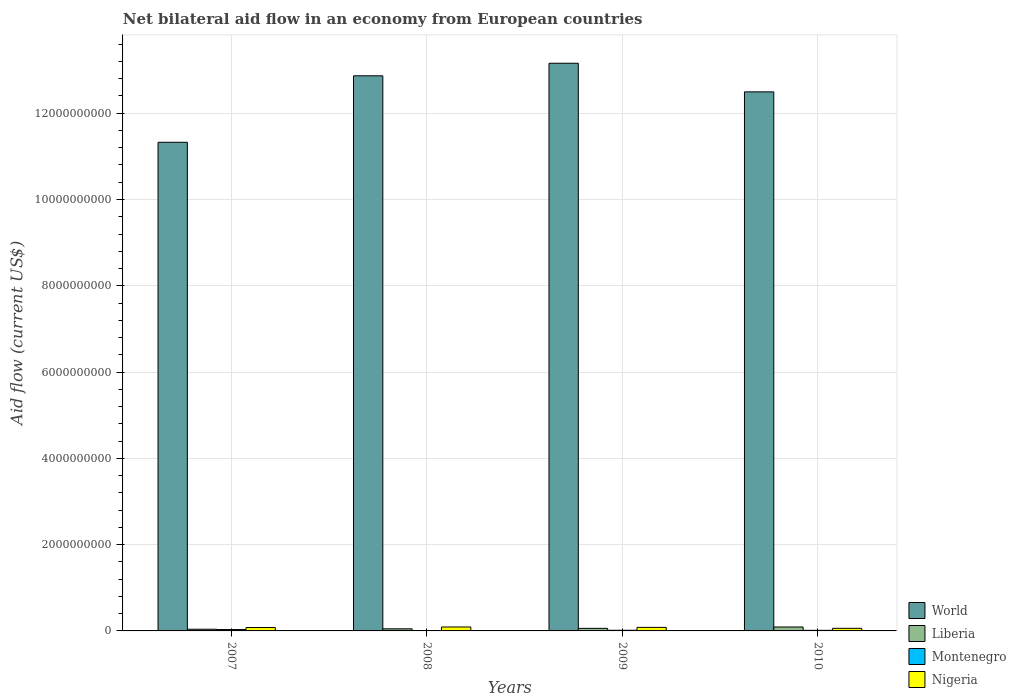How many groups of bars are there?
Your answer should be compact. 4. Are the number of bars per tick equal to the number of legend labels?
Your answer should be compact. Yes. Are the number of bars on each tick of the X-axis equal?
Ensure brevity in your answer.  Yes. How many bars are there on the 3rd tick from the left?
Provide a succinct answer. 4. How many bars are there on the 4th tick from the right?
Offer a very short reply. 4. What is the label of the 3rd group of bars from the left?
Offer a terse response. 2009. In how many cases, is the number of bars for a given year not equal to the number of legend labels?
Offer a very short reply. 0. What is the net bilateral aid flow in World in 2007?
Give a very brief answer. 1.13e+1. Across all years, what is the maximum net bilateral aid flow in World?
Keep it short and to the point. 1.32e+1. Across all years, what is the minimum net bilateral aid flow in Liberia?
Your response must be concise. 3.95e+07. In which year was the net bilateral aid flow in Liberia maximum?
Offer a very short reply. 2010. In which year was the net bilateral aid flow in Liberia minimum?
Give a very brief answer. 2007. What is the total net bilateral aid flow in World in the graph?
Provide a short and direct response. 4.98e+1. What is the difference between the net bilateral aid flow in Montenegro in 2008 and that in 2010?
Give a very brief answer. -4.20e+06. What is the difference between the net bilateral aid flow in Nigeria in 2007 and the net bilateral aid flow in Montenegro in 2008?
Your answer should be very brief. 6.90e+07. What is the average net bilateral aid flow in Montenegro per year?
Ensure brevity in your answer.  1.74e+07. In the year 2008, what is the difference between the net bilateral aid flow in World and net bilateral aid flow in Nigeria?
Make the answer very short. 1.28e+1. What is the ratio of the net bilateral aid flow in World in 2009 to that in 2010?
Your response must be concise. 1.05. Is the net bilateral aid flow in Liberia in 2007 less than that in 2010?
Your answer should be compact. Yes. Is the difference between the net bilateral aid flow in World in 2008 and 2010 greater than the difference between the net bilateral aid flow in Nigeria in 2008 and 2010?
Offer a very short reply. Yes. What is the difference between the highest and the second highest net bilateral aid flow in Montenegro?
Provide a short and direct response. 1.66e+07. What is the difference between the highest and the lowest net bilateral aid flow in Liberia?
Make the answer very short. 5.15e+07. In how many years, is the net bilateral aid flow in Liberia greater than the average net bilateral aid flow in Liberia taken over all years?
Offer a very short reply. 1. Is it the case that in every year, the sum of the net bilateral aid flow in Liberia and net bilateral aid flow in World is greater than the net bilateral aid flow in Montenegro?
Give a very brief answer. Yes. How many bars are there?
Your answer should be very brief. 16. Are the values on the major ticks of Y-axis written in scientific E-notation?
Make the answer very short. No. Does the graph contain any zero values?
Give a very brief answer. No. How are the legend labels stacked?
Offer a very short reply. Vertical. What is the title of the graph?
Provide a short and direct response. Net bilateral aid flow in an economy from European countries. What is the label or title of the X-axis?
Keep it short and to the point. Years. What is the label or title of the Y-axis?
Your answer should be very brief. Aid flow (current US$). What is the Aid flow (current US$) of World in 2007?
Ensure brevity in your answer.  1.13e+1. What is the Aid flow (current US$) of Liberia in 2007?
Keep it short and to the point. 3.95e+07. What is the Aid flow (current US$) in Montenegro in 2007?
Provide a succinct answer. 3.16e+07. What is the Aid flow (current US$) of Nigeria in 2007?
Offer a terse response. 7.85e+07. What is the Aid flow (current US$) of World in 2008?
Your answer should be very brief. 1.29e+1. What is the Aid flow (current US$) in Liberia in 2008?
Ensure brevity in your answer.  4.86e+07. What is the Aid flow (current US$) in Montenegro in 2008?
Give a very brief answer. 9.50e+06. What is the Aid flow (current US$) in Nigeria in 2008?
Offer a very short reply. 9.16e+07. What is the Aid flow (current US$) of World in 2009?
Keep it short and to the point. 1.32e+1. What is the Aid flow (current US$) in Liberia in 2009?
Keep it short and to the point. 5.95e+07. What is the Aid flow (current US$) of Montenegro in 2009?
Offer a very short reply. 1.50e+07. What is the Aid flow (current US$) in Nigeria in 2009?
Offer a terse response. 8.19e+07. What is the Aid flow (current US$) in World in 2010?
Keep it short and to the point. 1.25e+1. What is the Aid flow (current US$) of Liberia in 2010?
Your answer should be very brief. 9.09e+07. What is the Aid flow (current US$) in Montenegro in 2010?
Offer a terse response. 1.37e+07. What is the Aid flow (current US$) in Nigeria in 2010?
Provide a succinct answer. 6.03e+07. Across all years, what is the maximum Aid flow (current US$) of World?
Keep it short and to the point. 1.32e+1. Across all years, what is the maximum Aid flow (current US$) in Liberia?
Make the answer very short. 9.09e+07. Across all years, what is the maximum Aid flow (current US$) of Montenegro?
Offer a terse response. 3.16e+07. Across all years, what is the maximum Aid flow (current US$) in Nigeria?
Ensure brevity in your answer.  9.16e+07. Across all years, what is the minimum Aid flow (current US$) in World?
Give a very brief answer. 1.13e+1. Across all years, what is the minimum Aid flow (current US$) in Liberia?
Provide a short and direct response. 3.95e+07. Across all years, what is the minimum Aid flow (current US$) of Montenegro?
Offer a terse response. 9.50e+06. Across all years, what is the minimum Aid flow (current US$) of Nigeria?
Ensure brevity in your answer.  6.03e+07. What is the total Aid flow (current US$) in World in the graph?
Give a very brief answer. 4.98e+1. What is the total Aid flow (current US$) in Liberia in the graph?
Keep it short and to the point. 2.39e+08. What is the total Aid flow (current US$) of Montenegro in the graph?
Make the answer very short. 6.97e+07. What is the total Aid flow (current US$) of Nigeria in the graph?
Your answer should be compact. 3.12e+08. What is the difference between the Aid flow (current US$) in World in 2007 and that in 2008?
Provide a succinct answer. -1.54e+09. What is the difference between the Aid flow (current US$) in Liberia in 2007 and that in 2008?
Provide a short and direct response. -9.13e+06. What is the difference between the Aid flow (current US$) of Montenegro in 2007 and that in 2008?
Your answer should be compact. 2.21e+07. What is the difference between the Aid flow (current US$) in Nigeria in 2007 and that in 2008?
Your answer should be compact. -1.30e+07. What is the difference between the Aid flow (current US$) in World in 2007 and that in 2009?
Offer a terse response. -1.83e+09. What is the difference between the Aid flow (current US$) in Liberia in 2007 and that in 2009?
Offer a very short reply. -2.01e+07. What is the difference between the Aid flow (current US$) in Montenegro in 2007 and that in 2009?
Offer a terse response. 1.66e+07. What is the difference between the Aid flow (current US$) of Nigeria in 2007 and that in 2009?
Offer a terse response. -3.35e+06. What is the difference between the Aid flow (current US$) of World in 2007 and that in 2010?
Your answer should be compact. -1.17e+09. What is the difference between the Aid flow (current US$) in Liberia in 2007 and that in 2010?
Provide a succinct answer. -5.15e+07. What is the difference between the Aid flow (current US$) of Montenegro in 2007 and that in 2010?
Your answer should be compact. 1.79e+07. What is the difference between the Aid flow (current US$) in Nigeria in 2007 and that in 2010?
Provide a succinct answer. 1.82e+07. What is the difference between the Aid flow (current US$) of World in 2008 and that in 2009?
Make the answer very short. -2.91e+08. What is the difference between the Aid flow (current US$) in Liberia in 2008 and that in 2009?
Your answer should be very brief. -1.10e+07. What is the difference between the Aid flow (current US$) in Montenegro in 2008 and that in 2009?
Offer a very short reply. -5.47e+06. What is the difference between the Aid flow (current US$) of Nigeria in 2008 and that in 2009?
Your response must be concise. 9.69e+06. What is the difference between the Aid flow (current US$) of World in 2008 and that in 2010?
Your response must be concise. 3.73e+08. What is the difference between the Aid flow (current US$) of Liberia in 2008 and that in 2010?
Offer a very short reply. -4.23e+07. What is the difference between the Aid flow (current US$) in Montenegro in 2008 and that in 2010?
Offer a terse response. -4.20e+06. What is the difference between the Aid flow (current US$) in Nigeria in 2008 and that in 2010?
Make the answer very short. 3.13e+07. What is the difference between the Aid flow (current US$) of World in 2009 and that in 2010?
Your answer should be very brief. 6.63e+08. What is the difference between the Aid flow (current US$) in Liberia in 2009 and that in 2010?
Ensure brevity in your answer.  -3.14e+07. What is the difference between the Aid flow (current US$) of Montenegro in 2009 and that in 2010?
Give a very brief answer. 1.27e+06. What is the difference between the Aid flow (current US$) of Nigeria in 2009 and that in 2010?
Offer a terse response. 2.16e+07. What is the difference between the Aid flow (current US$) in World in 2007 and the Aid flow (current US$) in Liberia in 2008?
Ensure brevity in your answer.  1.13e+1. What is the difference between the Aid flow (current US$) of World in 2007 and the Aid flow (current US$) of Montenegro in 2008?
Offer a very short reply. 1.13e+1. What is the difference between the Aid flow (current US$) of World in 2007 and the Aid flow (current US$) of Nigeria in 2008?
Your answer should be very brief. 1.12e+1. What is the difference between the Aid flow (current US$) in Liberia in 2007 and the Aid flow (current US$) in Montenegro in 2008?
Provide a succinct answer. 3.00e+07. What is the difference between the Aid flow (current US$) in Liberia in 2007 and the Aid flow (current US$) in Nigeria in 2008?
Provide a succinct answer. -5.21e+07. What is the difference between the Aid flow (current US$) of Montenegro in 2007 and the Aid flow (current US$) of Nigeria in 2008?
Provide a short and direct response. -6.00e+07. What is the difference between the Aid flow (current US$) of World in 2007 and the Aid flow (current US$) of Liberia in 2009?
Your answer should be compact. 1.13e+1. What is the difference between the Aid flow (current US$) of World in 2007 and the Aid flow (current US$) of Montenegro in 2009?
Keep it short and to the point. 1.13e+1. What is the difference between the Aid flow (current US$) of World in 2007 and the Aid flow (current US$) of Nigeria in 2009?
Provide a succinct answer. 1.12e+1. What is the difference between the Aid flow (current US$) of Liberia in 2007 and the Aid flow (current US$) of Montenegro in 2009?
Offer a very short reply. 2.45e+07. What is the difference between the Aid flow (current US$) of Liberia in 2007 and the Aid flow (current US$) of Nigeria in 2009?
Offer a very short reply. -4.24e+07. What is the difference between the Aid flow (current US$) of Montenegro in 2007 and the Aid flow (current US$) of Nigeria in 2009?
Provide a short and direct response. -5.03e+07. What is the difference between the Aid flow (current US$) in World in 2007 and the Aid flow (current US$) in Liberia in 2010?
Your answer should be very brief. 1.12e+1. What is the difference between the Aid flow (current US$) of World in 2007 and the Aid flow (current US$) of Montenegro in 2010?
Offer a very short reply. 1.13e+1. What is the difference between the Aid flow (current US$) in World in 2007 and the Aid flow (current US$) in Nigeria in 2010?
Give a very brief answer. 1.13e+1. What is the difference between the Aid flow (current US$) of Liberia in 2007 and the Aid flow (current US$) of Montenegro in 2010?
Ensure brevity in your answer.  2.58e+07. What is the difference between the Aid flow (current US$) of Liberia in 2007 and the Aid flow (current US$) of Nigeria in 2010?
Offer a very short reply. -2.08e+07. What is the difference between the Aid flow (current US$) in Montenegro in 2007 and the Aid flow (current US$) in Nigeria in 2010?
Your answer should be very brief. -2.87e+07. What is the difference between the Aid flow (current US$) of World in 2008 and the Aid flow (current US$) of Liberia in 2009?
Offer a terse response. 1.28e+1. What is the difference between the Aid flow (current US$) of World in 2008 and the Aid flow (current US$) of Montenegro in 2009?
Your response must be concise. 1.29e+1. What is the difference between the Aid flow (current US$) of World in 2008 and the Aid flow (current US$) of Nigeria in 2009?
Offer a terse response. 1.28e+1. What is the difference between the Aid flow (current US$) in Liberia in 2008 and the Aid flow (current US$) in Montenegro in 2009?
Provide a succinct answer. 3.36e+07. What is the difference between the Aid flow (current US$) of Liberia in 2008 and the Aid flow (current US$) of Nigeria in 2009?
Offer a terse response. -3.33e+07. What is the difference between the Aid flow (current US$) in Montenegro in 2008 and the Aid flow (current US$) in Nigeria in 2009?
Ensure brevity in your answer.  -7.24e+07. What is the difference between the Aid flow (current US$) in World in 2008 and the Aid flow (current US$) in Liberia in 2010?
Offer a terse response. 1.28e+1. What is the difference between the Aid flow (current US$) of World in 2008 and the Aid flow (current US$) of Montenegro in 2010?
Offer a very short reply. 1.29e+1. What is the difference between the Aid flow (current US$) in World in 2008 and the Aid flow (current US$) in Nigeria in 2010?
Provide a short and direct response. 1.28e+1. What is the difference between the Aid flow (current US$) of Liberia in 2008 and the Aid flow (current US$) of Montenegro in 2010?
Offer a very short reply. 3.49e+07. What is the difference between the Aid flow (current US$) in Liberia in 2008 and the Aid flow (current US$) in Nigeria in 2010?
Your response must be concise. -1.17e+07. What is the difference between the Aid flow (current US$) of Montenegro in 2008 and the Aid flow (current US$) of Nigeria in 2010?
Offer a very short reply. -5.08e+07. What is the difference between the Aid flow (current US$) of World in 2009 and the Aid flow (current US$) of Liberia in 2010?
Your response must be concise. 1.31e+1. What is the difference between the Aid flow (current US$) of World in 2009 and the Aid flow (current US$) of Montenegro in 2010?
Offer a terse response. 1.31e+1. What is the difference between the Aid flow (current US$) of World in 2009 and the Aid flow (current US$) of Nigeria in 2010?
Make the answer very short. 1.31e+1. What is the difference between the Aid flow (current US$) of Liberia in 2009 and the Aid flow (current US$) of Montenegro in 2010?
Provide a succinct answer. 4.58e+07. What is the difference between the Aid flow (current US$) in Liberia in 2009 and the Aid flow (current US$) in Nigeria in 2010?
Your response must be concise. -7.50e+05. What is the difference between the Aid flow (current US$) of Montenegro in 2009 and the Aid flow (current US$) of Nigeria in 2010?
Give a very brief answer. -4.53e+07. What is the average Aid flow (current US$) in World per year?
Offer a very short reply. 1.25e+1. What is the average Aid flow (current US$) of Liberia per year?
Provide a succinct answer. 5.96e+07. What is the average Aid flow (current US$) in Montenegro per year?
Offer a terse response. 1.74e+07. What is the average Aid flow (current US$) in Nigeria per year?
Make the answer very short. 7.81e+07. In the year 2007, what is the difference between the Aid flow (current US$) of World and Aid flow (current US$) of Liberia?
Provide a succinct answer. 1.13e+1. In the year 2007, what is the difference between the Aid flow (current US$) in World and Aid flow (current US$) in Montenegro?
Make the answer very short. 1.13e+1. In the year 2007, what is the difference between the Aid flow (current US$) in World and Aid flow (current US$) in Nigeria?
Keep it short and to the point. 1.12e+1. In the year 2007, what is the difference between the Aid flow (current US$) in Liberia and Aid flow (current US$) in Montenegro?
Provide a short and direct response. 7.89e+06. In the year 2007, what is the difference between the Aid flow (current US$) in Liberia and Aid flow (current US$) in Nigeria?
Your response must be concise. -3.90e+07. In the year 2007, what is the difference between the Aid flow (current US$) of Montenegro and Aid flow (current US$) of Nigeria?
Your answer should be compact. -4.69e+07. In the year 2008, what is the difference between the Aid flow (current US$) of World and Aid flow (current US$) of Liberia?
Offer a very short reply. 1.28e+1. In the year 2008, what is the difference between the Aid flow (current US$) of World and Aid flow (current US$) of Montenegro?
Offer a very short reply. 1.29e+1. In the year 2008, what is the difference between the Aid flow (current US$) in World and Aid flow (current US$) in Nigeria?
Keep it short and to the point. 1.28e+1. In the year 2008, what is the difference between the Aid flow (current US$) in Liberia and Aid flow (current US$) in Montenegro?
Offer a very short reply. 3.91e+07. In the year 2008, what is the difference between the Aid flow (current US$) of Liberia and Aid flow (current US$) of Nigeria?
Keep it short and to the point. -4.30e+07. In the year 2008, what is the difference between the Aid flow (current US$) in Montenegro and Aid flow (current US$) in Nigeria?
Offer a very short reply. -8.20e+07. In the year 2009, what is the difference between the Aid flow (current US$) of World and Aid flow (current US$) of Liberia?
Offer a terse response. 1.31e+1. In the year 2009, what is the difference between the Aid flow (current US$) in World and Aid flow (current US$) in Montenegro?
Offer a terse response. 1.31e+1. In the year 2009, what is the difference between the Aid flow (current US$) in World and Aid flow (current US$) in Nigeria?
Offer a terse response. 1.31e+1. In the year 2009, what is the difference between the Aid flow (current US$) of Liberia and Aid flow (current US$) of Montenegro?
Ensure brevity in your answer.  4.46e+07. In the year 2009, what is the difference between the Aid flow (current US$) in Liberia and Aid flow (current US$) in Nigeria?
Your answer should be compact. -2.23e+07. In the year 2009, what is the difference between the Aid flow (current US$) in Montenegro and Aid flow (current US$) in Nigeria?
Ensure brevity in your answer.  -6.69e+07. In the year 2010, what is the difference between the Aid flow (current US$) in World and Aid flow (current US$) in Liberia?
Your answer should be very brief. 1.24e+1. In the year 2010, what is the difference between the Aid flow (current US$) in World and Aid flow (current US$) in Montenegro?
Provide a succinct answer. 1.25e+1. In the year 2010, what is the difference between the Aid flow (current US$) in World and Aid flow (current US$) in Nigeria?
Make the answer very short. 1.24e+1. In the year 2010, what is the difference between the Aid flow (current US$) in Liberia and Aid flow (current US$) in Montenegro?
Give a very brief answer. 7.72e+07. In the year 2010, what is the difference between the Aid flow (current US$) in Liberia and Aid flow (current US$) in Nigeria?
Keep it short and to the point. 3.06e+07. In the year 2010, what is the difference between the Aid flow (current US$) of Montenegro and Aid flow (current US$) of Nigeria?
Your response must be concise. -4.66e+07. What is the ratio of the Aid flow (current US$) in World in 2007 to that in 2008?
Offer a terse response. 0.88. What is the ratio of the Aid flow (current US$) of Liberia in 2007 to that in 2008?
Make the answer very short. 0.81. What is the ratio of the Aid flow (current US$) in Montenegro in 2007 to that in 2008?
Your answer should be very brief. 3.32. What is the ratio of the Aid flow (current US$) of Nigeria in 2007 to that in 2008?
Your response must be concise. 0.86. What is the ratio of the Aid flow (current US$) of World in 2007 to that in 2009?
Give a very brief answer. 0.86. What is the ratio of the Aid flow (current US$) in Liberia in 2007 to that in 2009?
Provide a succinct answer. 0.66. What is the ratio of the Aid flow (current US$) in Montenegro in 2007 to that in 2009?
Offer a terse response. 2.11. What is the ratio of the Aid flow (current US$) of Nigeria in 2007 to that in 2009?
Offer a very short reply. 0.96. What is the ratio of the Aid flow (current US$) of World in 2007 to that in 2010?
Offer a terse response. 0.91. What is the ratio of the Aid flow (current US$) of Liberia in 2007 to that in 2010?
Your response must be concise. 0.43. What is the ratio of the Aid flow (current US$) in Montenegro in 2007 to that in 2010?
Give a very brief answer. 2.3. What is the ratio of the Aid flow (current US$) of Nigeria in 2007 to that in 2010?
Provide a succinct answer. 1.3. What is the ratio of the Aid flow (current US$) in World in 2008 to that in 2009?
Provide a short and direct response. 0.98. What is the ratio of the Aid flow (current US$) in Liberia in 2008 to that in 2009?
Offer a very short reply. 0.82. What is the ratio of the Aid flow (current US$) of Montenegro in 2008 to that in 2009?
Ensure brevity in your answer.  0.63. What is the ratio of the Aid flow (current US$) in Nigeria in 2008 to that in 2009?
Keep it short and to the point. 1.12. What is the ratio of the Aid flow (current US$) of World in 2008 to that in 2010?
Your answer should be compact. 1.03. What is the ratio of the Aid flow (current US$) of Liberia in 2008 to that in 2010?
Offer a terse response. 0.53. What is the ratio of the Aid flow (current US$) in Montenegro in 2008 to that in 2010?
Offer a terse response. 0.69. What is the ratio of the Aid flow (current US$) of Nigeria in 2008 to that in 2010?
Your response must be concise. 1.52. What is the ratio of the Aid flow (current US$) in World in 2009 to that in 2010?
Your answer should be compact. 1.05. What is the ratio of the Aid flow (current US$) in Liberia in 2009 to that in 2010?
Keep it short and to the point. 0.65. What is the ratio of the Aid flow (current US$) of Montenegro in 2009 to that in 2010?
Ensure brevity in your answer.  1.09. What is the ratio of the Aid flow (current US$) in Nigeria in 2009 to that in 2010?
Offer a terse response. 1.36. What is the difference between the highest and the second highest Aid flow (current US$) of World?
Your answer should be compact. 2.91e+08. What is the difference between the highest and the second highest Aid flow (current US$) of Liberia?
Your answer should be compact. 3.14e+07. What is the difference between the highest and the second highest Aid flow (current US$) in Montenegro?
Your answer should be very brief. 1.66e+07. What is the difference between the highest and the second highest Aid flow (current US$) in Nigeria?
Keep it short and to the point. 9.69e+06. What is the difference between the highest and the lowest Aid flow (current US$) in World?
Your answer should be very brief. 1.83e+09. What is the difference between the highest and the lowest Aid flow (current US$) of Liberia?
Provide a succinct answer. 5.15e+07. What is the difference between the highest and the lowest Aid flow (current US$) of Montenegro?
Your response must be concise. 2.21e+07. What is the difference between the highest and the lowest Aid flow (current US$) in Nigeria?
Make the answer very short. 3.13e+07. 